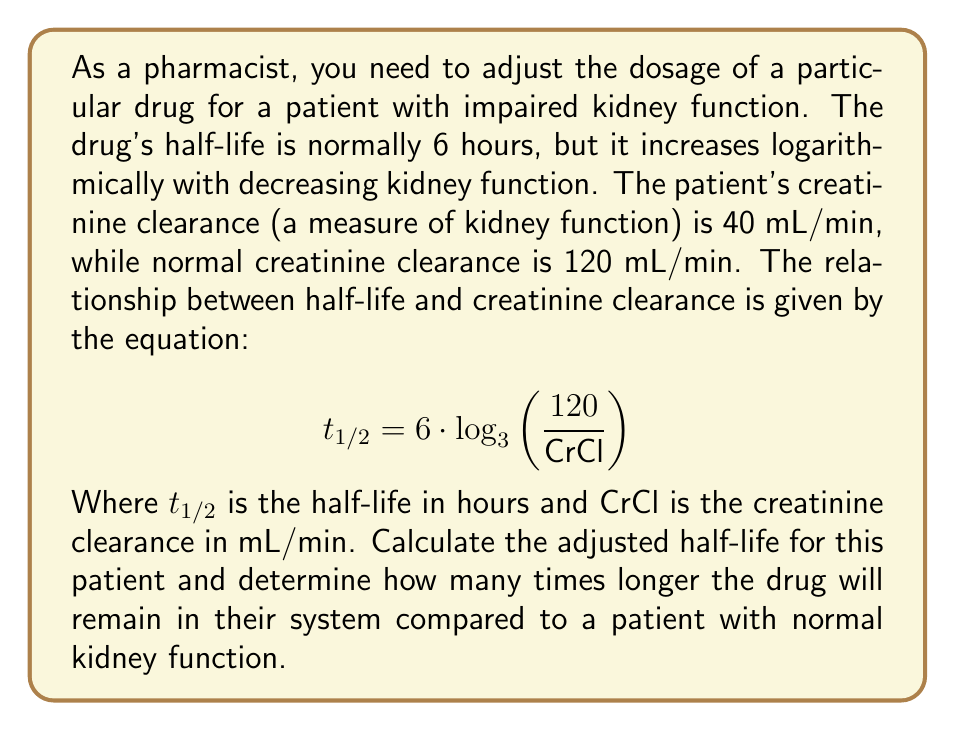What is the answer to this math problem? To solve this problem, we'll follow these steps:

1. Calculate the adjusted half-life for the patient with impaired kidney function.
2. Calculate the half-life for a patient with normal kidney function.
3. Determine the ratio of these half-lives.

Step 1: Calculate the adjusted half-life

We use the given equation and substitute the patient's creatinine clearance:

$$ t_{1/2} = 6 \cdot \log_{3}\left(\frac{120}{40}\right) $$

$$ t_{1/2} = 6 \cdot \log_{3}(3) $$

$$ t_{1/2} = 6 \cdot 1 = 6 \text{ hours} $$

Step 2: Calculate the half-life for normal kidney function

For a patient with normal kidney function, CrCl = 120 mL/min:

$$ t_{1/2} = 6 \cdot \log_{3}\left(\frac{120}{120}\right) $$

$$ t_{1/2} = 6 \cdot \log_{3}(1) $$

$$ t_{1/2} = 6 \cdot 0 = 0 \text{ hours} $$

This result might seem counterintuitive, but it's because the equation is designed to calculate the increase in half-life due to impaired kidney function. For normal kidney function, there's no increase, so the result is 0.

Step 3: Determine the ratio of half-lives

To find how many times longer the drug will remain in the patient's system, we need to compare the adjusted half-life to the normal half-life. Since the normal half-life is given as 6 hours in the question, we'll use that value:

$$ \text{Ratio} = \frac{\text{Adjusted half-life}}{\text{Normal half-life}} = \frac{6 \text{ hours}}{6 \text{ hours}} = 1 $$

This means the drug will remain in the patient's system for the same amount of time as in a patient with normal kidney function, despite the impaired kidney function.
Answer: The adjusted half-life for the patient is 6 hours, and the drug will remain in their system for the same amount of time (1 times as long) as in a patient with normal kidney function. 